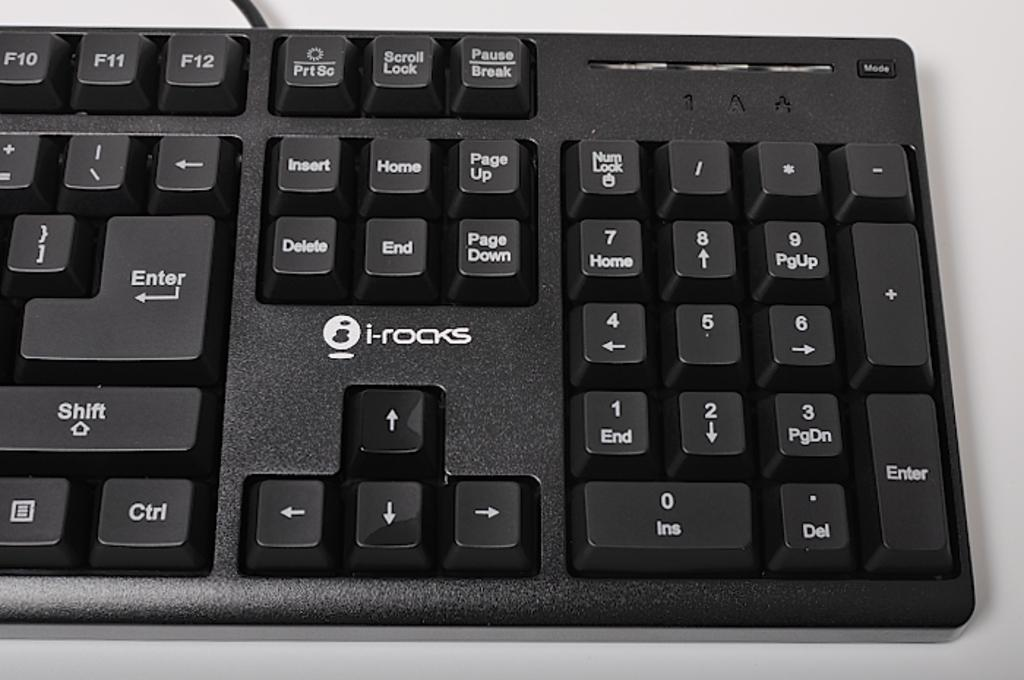<image>
Write a terse but informative summary of the picture. A keyboard that is black and by the brand "i-rocks". 